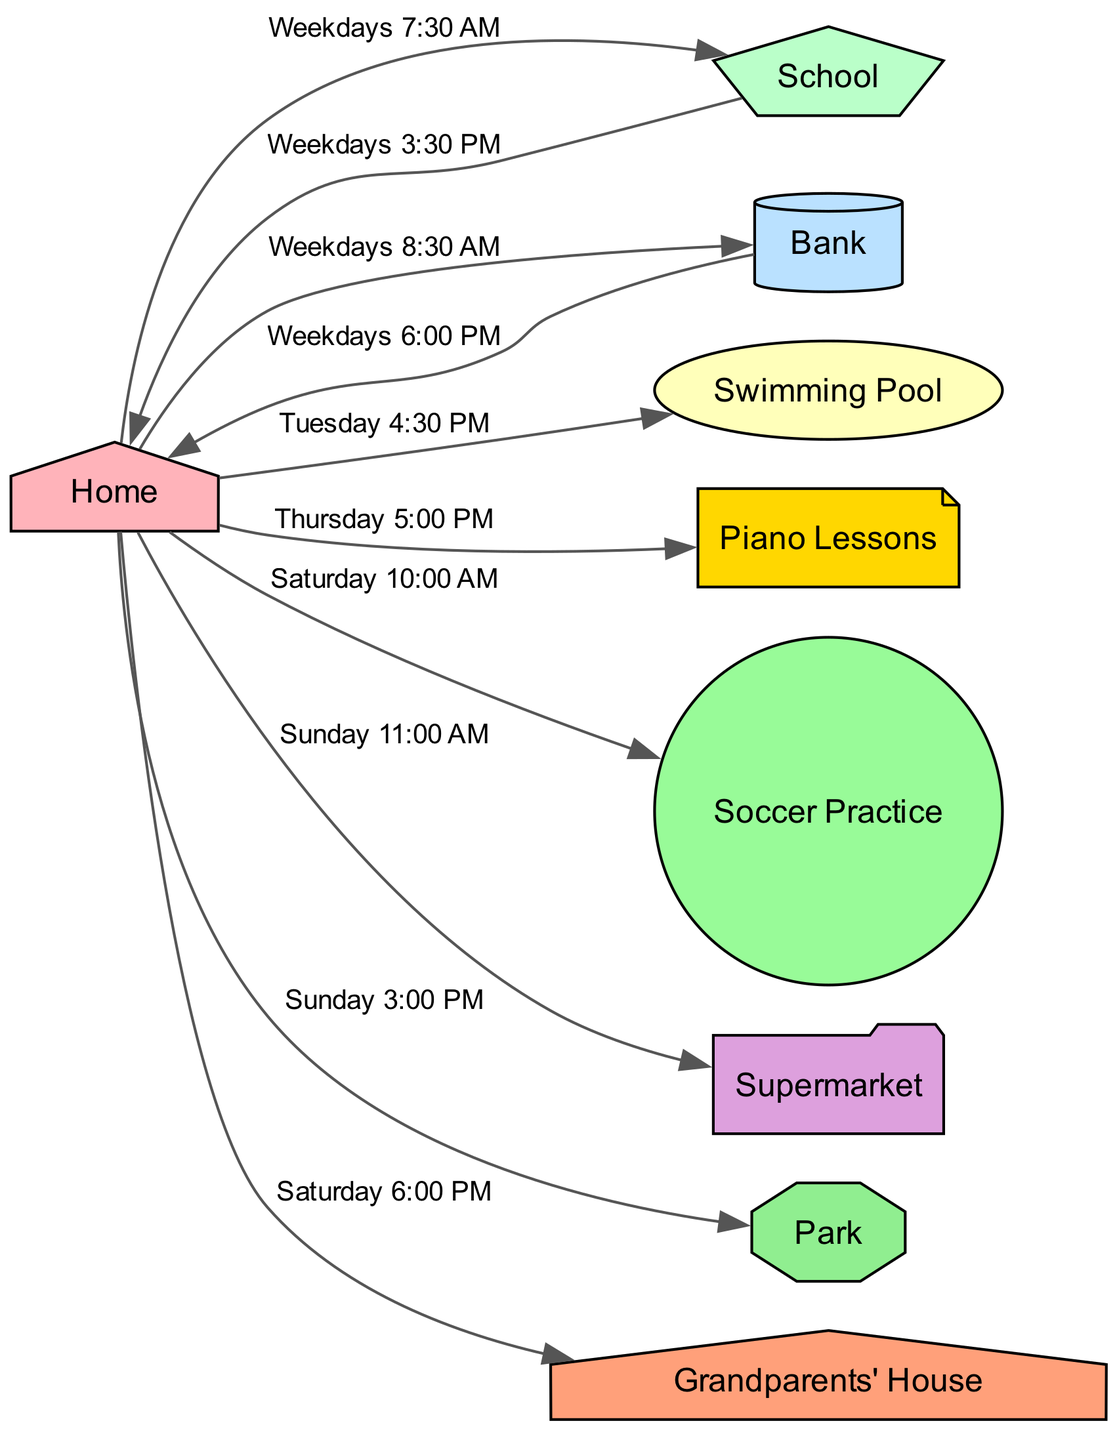What is the first activity after leaving Home on a weekday? The directed edge from "Home" indicates that the first activity is "School" at "Weekdays 7:30 AM."
Answer: School How many nodes are in the family schedule diagram? The diagram lists 9 unique locations as nodes: Home, School, Bank, Swimming Pool, Piano Lessons, Soccer Practice, Supermarket, Park, Grandparents' House. Counting these nodes gives a total of 9.
Answer: 9 Which activity is scheduled at 4:30 PM on Tuesday? Following the edge that leads from "Home" to "Swimming Pool" on the specified time, the activity taking place is "Swimming Pool at Tuesday 4:30 PM."
Answer: Swimming Pool What destination is visited after Soccer Practice on Saturday? Analyzing the edges, after "Home" leading to "Soccer Practice," there is no direct edge leading elsewhere on Saturday indicated in the schedule, suggesting there is no further activity listed for that day.
Answer: None How many trips are made from Home to Bank on weekdays? The directed edges show two trips: from "Home" to "Bank" at "Weekdays 8:30 AM" and then back from "Bank" to "Home" at "Weekdays 6:00 PM," counting this as one round trip means there are two trips made: to and from.
Answer: 2 What is the last activity of the week? The last scheduled activity happens at "Grandparents' House" from "Home" at "Saturday 6:00 PM," making it the final destination in the flow.
Answer: Grandparents' House How many activities take place on Sunday? The diagram shows two activities occurring on Sunday: "Supermarket" at "11:00 AM" and "Park" at "3:00 PM." Thus, there are two distinct activities scheduled on this day.
Answer: 2 What shape is used for the Bank in the diagram? The node "Bank" is represented as a "cylinder" in the directed graph, which is indicated by its specific designation in the diagram attributes.
Answer: Cylinder Which day features Piano Lessons? The scheduled activity for "Piano Lessons" occurs on "Thursday" at "5:00 PM" as indicated in the edge connecting "Home" to "Piano Lessons."
Answer: Thursday 